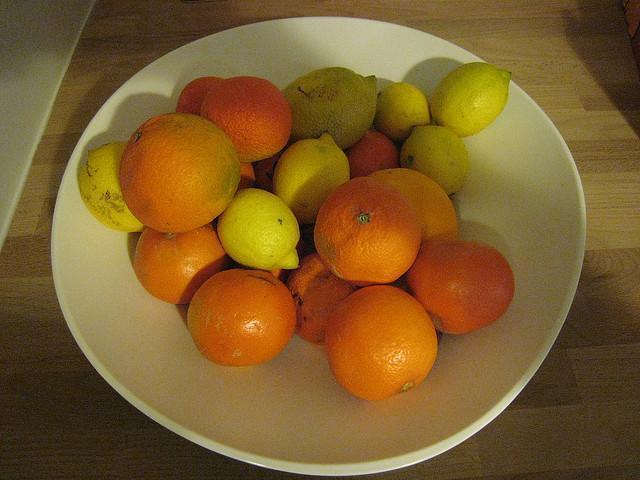Where do lemons originally come from?
Make your selection and explain in format: 'Answer: answer
Rationale: rationale.'
Options: Wales, unknown, ethiopia, france. Answer: unknown.
Rationale: No one knows the origin of lemons. 